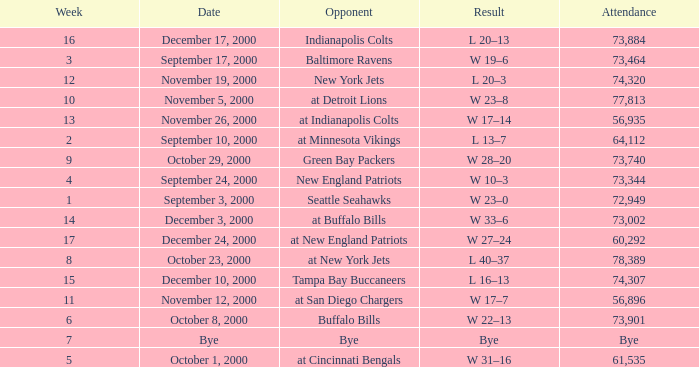What is the Result of the game against the Indianapolis Colts? L 20–13. Give me the full table as a dictionary. {'header': ['Week', 'Date', 'Opponent', 'Result', 'Attendance'], 'rows': [['16', 'December 17, 2000', 'Indianapolis Colts', 'L 20–13', '73,884'], ['3', 'September 17, 2000', 'Baltimore Ravens', 'W 19–6', '73,464'], ['12', 'November 19, 2000', 'New York Jets', 'L 20–3', '74,320'], ['10', 'November 5, 2000', 'at Detroit Lions', 'W 23–8', '77,813'], ['13', 'November 26, 2000', 'at Indianapolis Colts', 'W 17–14', '56,935'], ['2', 'September 10, 2000', 'at Minnesota Vikings', 'L 13–7', '64,112'], ['9', 'October 29, 2000', 'Green Bay Packers', 'W 28–20', '73,740'], ['4', 'September 24, 2000', 'New England Patriots', 'W 10–3', '73,344'], ['1', 'September 3, 2000', 'Seattle Seahawks', 'W 23–0', '72,949'], ['14', 'December 3, 2000', 'at Buffalo Bills', 'W 33–6', '73,002'], ['17', 'December 24, 2000', 'at New England Patriots', 'W 27–24', '60,292'], ['8', 'October 23, 2000', 'at New York Jets', 'L 40–37', '78,389'], ['15', 'December 10, 2000', 'Tampa Bay Buccaneers', 'L 16–13', '74,307'], ['11', 'November 12, 2000', 'at San Diego Chargers', 'W 17–7', '56,896'], ['6', 'October 8, 2000', 'Buffalo Bills', 'W 22–13', '73,901'], ['7', 'Bye', 'Bye', 'Bye', 'Bye'], ['5', 'October 1, 2000', 'at Cincinnati Bengals', 'W 31–16', '61,535']]} 